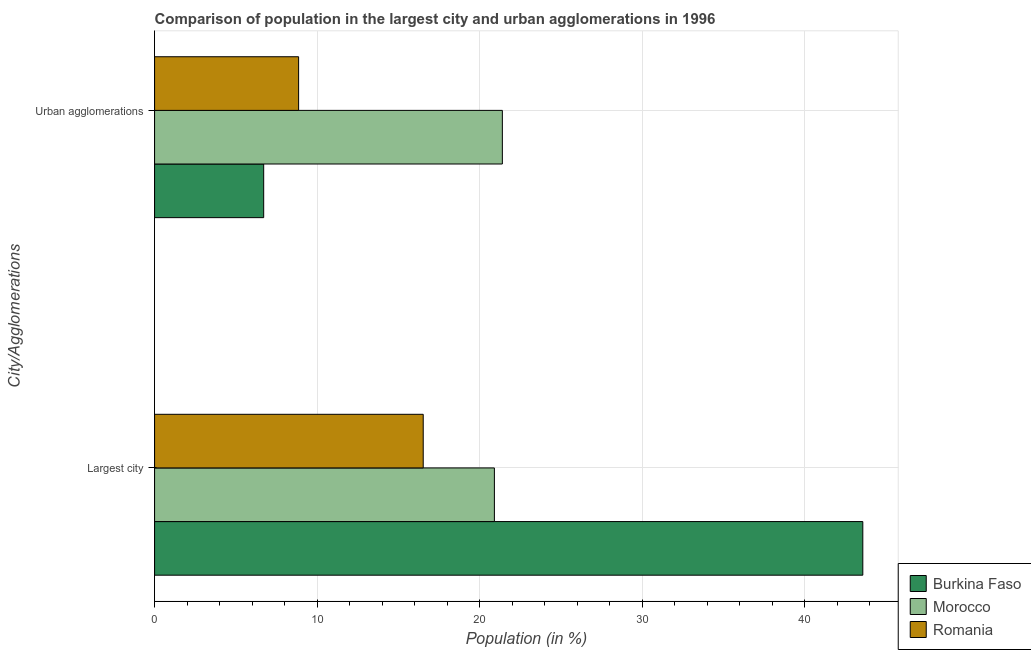How many different coloured bars are there?
Provide a short and direct response. 3. How many groups of bars are there?
Your answer should be very brief. 2. Are the number of bars per tick equal to the number of legend labels?
Provide a succinct answer. Yes. How many bars are there on the 1st tick from the bottom?
Provide a short and direct response. 3. What is the label of the 2nd group of bars from the top?
Ensure brevity in your answer.  Largest city. What is the population in the largest city in Romania?
Provide a succinct answer. 16.53. Across all countries, what is the maximum population in the largest city?
Offer a very short reply. 43.57. Across all countries, what is the minimum population in urban agglomerations?
Offer a terse response. 6.71. In which country was the population in urban agglomerations maximum?
Offer a terse response. Morocco. In which country was the population in urban agglomerations minimum?
Offer a very short reply. Burkina Faso. What is the total population in the largest city in the graph?
Offer a terse response. 81. What is the difference between the population in the largest city in Morocco and that in Burkina Faso?
Make the answer very short. -22.67. What is the difference between the population in the largest city in Romania and the population in urban agglomerations in Burkina Faso?
Provide a short and direct response. 9.81. What is the average population in the largest city per country?
Provide a short and direct response. 27. What is the difference between the population in the largest city and population in urban agglomerations in Burkina Faso?
Provide a short and direct response. 36.86. What is the ratio of the population in urban agglomerations in Romania to that in Burkina Faso?
Your response must be concise. 1.32. Is the population in the largest city in Morocco less than that in Burkina Faso?
Make the answer very short. Yes. What does the 2nd bar from the top in Largest city represents?
Offer a terse response. Morocco. What does the 2nd bar from the bottom in Urban agglomerations represents?
Your answer should be very brief. Morocco. What is the difference between two consecutive major ticks on the X-axis?
Offer a very short reply. 10. Are the values on the major ticks of X-axis written in scientific E-notation?
Provide a short and direct response. No. Does the graph contain any zero values?
Offer a very short reply. No. Does the graph contain grids?
Offer a very short reply. Yes. How many legend labels are there?
Make the answer very short. 3. What is the title of the graph?
Offer a terse response. Comparison of population in the largest city and urban agglomerations in 1996. Does "Zimbabwe" appear as one of the legend labels in the graph?
Your response must be concise. No. What is the label or title of the Y-axis?
Offer a terse response. City/Agglomerations. What is the Population (in %) of Burkina Faso in Largest city?
Ensure brevity in your answer.  43.57. What is the Population (in %) in Morocco in Largest city?
Offer a very short reply. 20.9. What is the Population (in %) of Romania in Largest city?
Provide a succinct answer. 16.53. What is the Population (in %) in Burkina Faso in Urban agglomerations?
Provide a succinct answer. 6.71. What is the Population (in %) of Morocco in Urban agglomerations?
Make the answer very short. 21.4. What is the Population (in %) in Romania in Urban agglomerations?
Your response must be concise. 8.86. Across all City/Agglomerations, what is the maximum Population (in %) of Burkina Faso?
Your answer should be very brief. 43.57. Across all City/Agglomerations, what is the maximum Population (in %) in Morocco?
Your answer should be compact. 21.4. Across all City/Agglomerations, what is the maximum Population (in %) in Romania?
Ensure brevity in your answer.  16.53. Across all City/Agglomerations, what is the minimum Population (in %) in Burkina Faso?
Provide a short and direct response. 6.71. Across all City/Agglomerations, what is the minimum Population (in %) in Morocco?
Give a very brief answer. 20.9. Across all City/Agglomerations, what is the minimum Population (in %) of Romania?
Provide a short and direct response. 8.86. What is the total Population (in %) of Burkina Faso in the graph?
Ensure brevity in your answer.  50.28. What is the total Population (in %) of Morocco in the graph?
Provide a short and direct response. 42.3. What is the total Population (in %) in Romania in the graph?
Your answer should be very brief. 25.39. What is the difference between the Population (in %) in Burkina Faso in Largest city and that in Urban agglomerations?
Your answer should be very brief. 36.86. What is the difference between the Population (in %) of Morocco in Largest city and that in Urban agglomerations?
Your answer should be very brief. -0.49. What is the difference between the Population (in %) in Romania in Largest city and that in Urban agglomerations?
Your answer should be very brief. 7.67. What is the difference between the Population (in %) in Burkina Faso in Largest city and the Population (in %) in Morocco in Urban agglomerations?
Keep it short and to the point. 22.17. What is the difference between the Population (in %) of Burkina Faso in Largest city and the Population (in %) of Romania in Urban agglomerations?
Make the answer very short. 34.71. What is the difference between the Population (in %) in Morocco in Largest city and the Population (in %) in Romania in Urban agglomerations?
Offer a terse response. 12.04. What is the average Population (in %) of Burkina Faso per City/Agglomerations?
Offer a very short reply. 25.14. What is the average Population (in %) in Morocco per City/Agglomerations?
Provide a short and direct response. 21.15. What is the average Population (in %) in Romania per City/Agglomerations?
Ensure brevity in your answer.  12.69. What is the difference between the Population (in %) of Burkina Faso and Population (in %) of Morocco in Largest city?
Your answer should be very brief. 22.67. What is the difference between the Population (in %) in Burkina Faso and Population (in %) in Romania in Largest city?
Your response must be concise. 27.04. What is the difference between the Population (in %) in Morocco and Population (in %) in Romania in Largest city?
Ensure brevity in your answer.  4.38. What is the difference between the Population (in %) of Burkina Faso and Population (in %) of Morocco in Urban agglomerations?
Offer a terse response. -14.68. What is the difference between the Population (in %) of Burkina Faso and Population (in %) of Romania in Urban agglomerations?
Make the answer very short. -2.15. What is the difference between the Population (in %) of Morocco and Population (in %) of Romania in Urban agglomerations?
Your answer should be very brief. 12.53. What is the ratio of the Population (in %) of Burkina Faso in Largest city to that in Urban agglomerations?
Provide a short and direct response. 6.49. What is the ratio of the Population (in %) of Morocco in Largest city to that in Urban agglomerations?
Give a very brief answer. 0.98. What is the ratio of the Population (in %) in Romania in Largest city to that in Urban agglomerations?
Offer a very short reply. 1.87. What is the difference between the highest and the second highest Population (in %) of Burkina Faso?
Offer a very short reply. 36.86. What is the difference between the highest and the second highest Population (in %) in Morocco?
Provide a short and direct response. 0.49. What is the difference between the highest and the second highest Population (in %) of Romania?
Your answer should be very brief. 7.67. What is the difference between the highest and the lowest Population (in %) in Burkina Faso?
Provide a short and direct response. 36.86. What is the difference between the highest and the lowest Population (in %) of Morocco?
Give a very brief answer. 0.49. What is the difference between the highest and the lowest Population (in %) of Romania?
Ensure brevity in your answer.  7.67. 